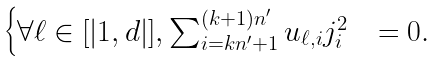<formula> <loc_0><loc_0><loc_500><loc_500>\begin{cases} \forall \ell \in [ | 1 , d | ] , \sum _ { i = k n ^ { \prime } + 1 } ^ { ( k + 1 ) n ^ { \prime } } u _ { \ell , i } j _ { i } ^ { 2 } & = 0 . \\ \end{cases}</formula> 